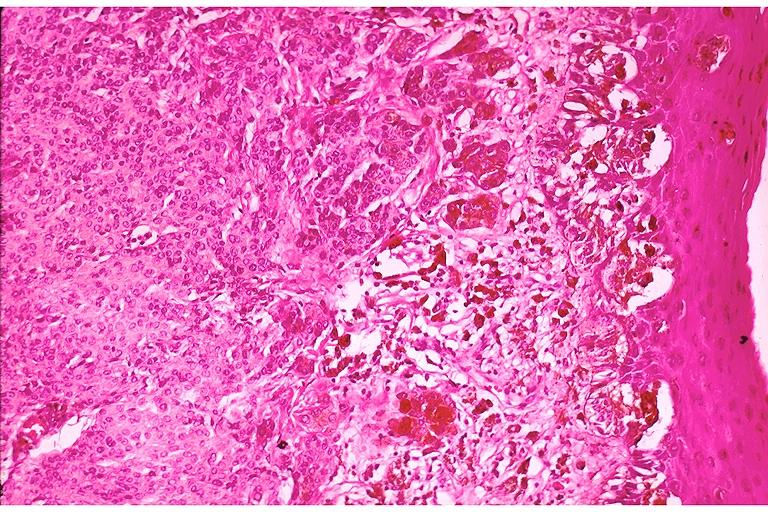where is this?
Answer the question using a single word or phrase. Oral 